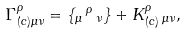Convert formula to latex. <formula><loc_0><loc_0><loc_500><loc_500>\Gamma _ { ( c ) \mu \nu } ^ { \rho } = \{ _ { \mu } \, ^ { \rho } \, _ { \nu } \} + K _ { ( c ) } ^ { \rho } \, _ { \mu \nu } ,</formula> 